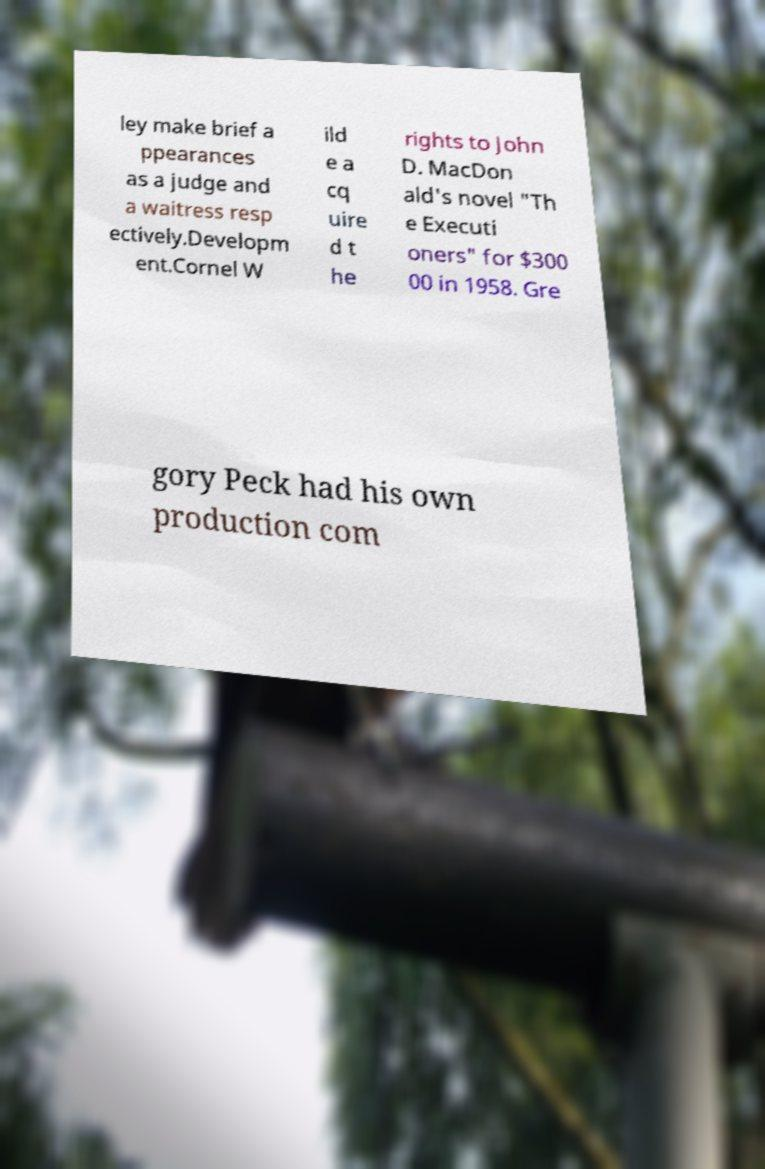Could you assist in decoding the text presented in this image and type it out clearly? ley make brief a ppearances as a judge and a waitress resp ectively.Developm ent.Cornel W ild e a cq uire d t he rights to John D. MacDon ald's novel "Th e Executi oners" for $300 00 in 1958. Gre gory Peck had his own production com 